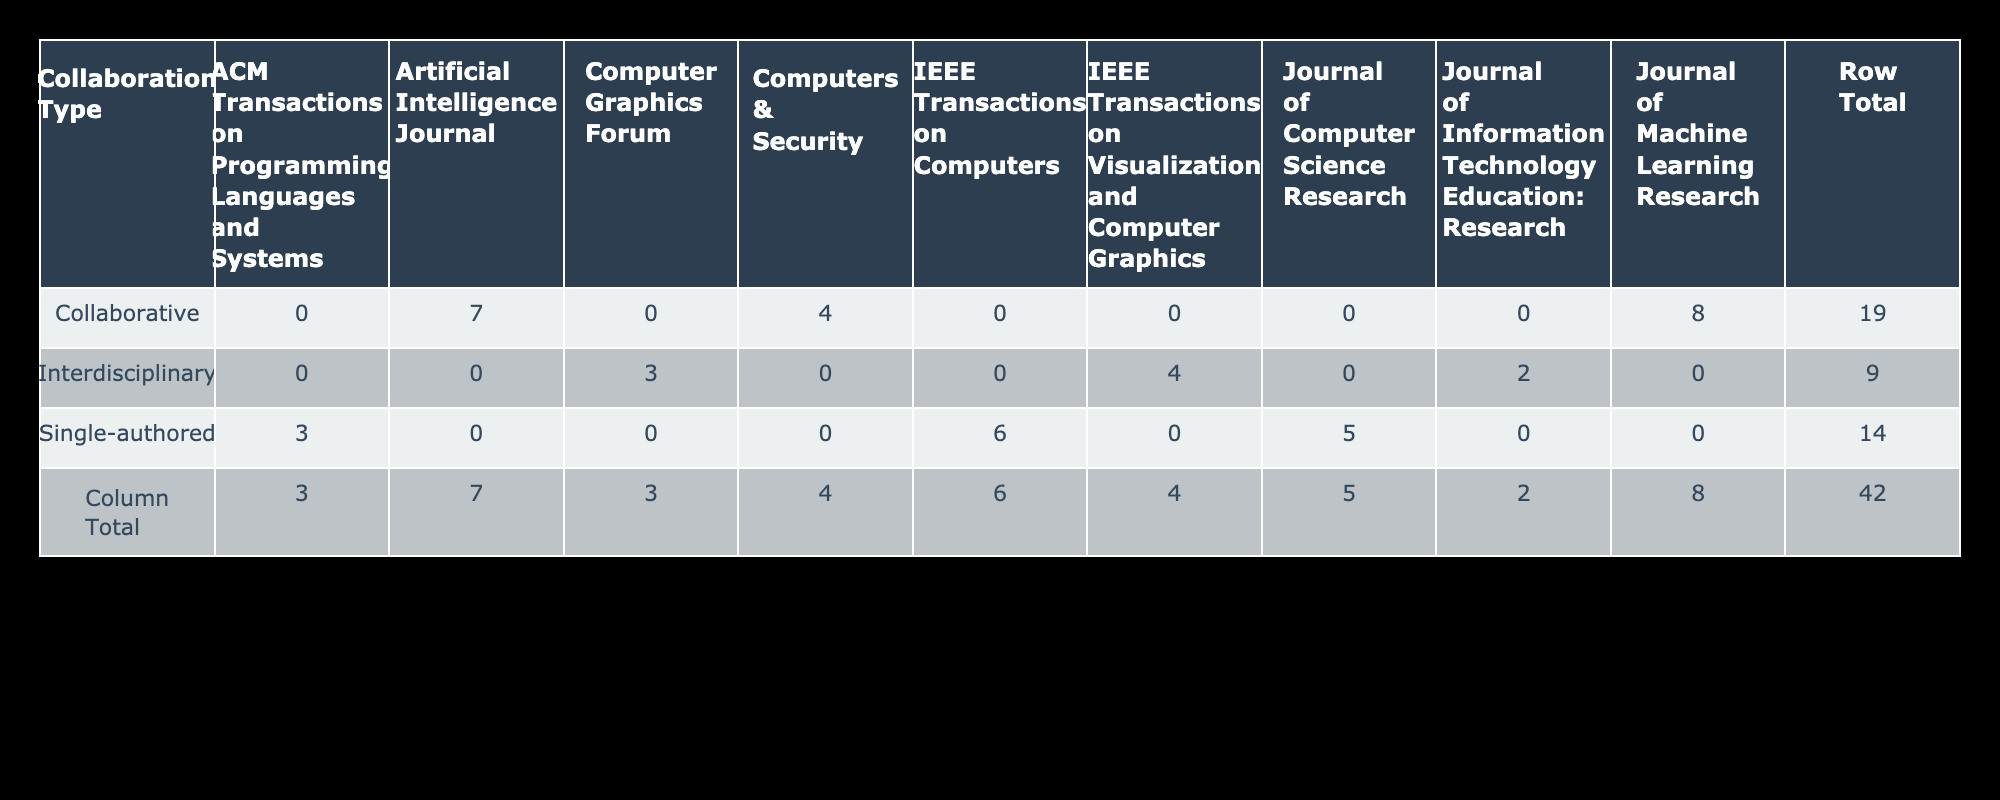What is the total number of publications for collaborative research? The table shows the publications for various collaboration types. For "Collaborative," there are 8 publications from the Journal of Machine Learning Research, 4 from Computers & Security, and 7 from Artificial Intelligence Journal. Adding these gives a total of 8 + 4 + 7 = 19 publications.
Answer: 19 Which journal has the highest impact factor among those listed? The impact factors of the listed journals are 3.2, 2.8, 4.1 for single-authored, 6.5, 4.3, 5.7 for collaborative, and 2.3, 3.8, 4.9 for interdisciplinary. The highest is 6.5 from the Journal of Machine Learning Research.
Answer: 6.5 Are there any single-authored publications in journals with an impact factor higher than 4.0? The impact factors for single-authored journals are 3.2, 2.8, and 4.1. Since 4.1 is the only single-authored journal that exceeds 4.0, the answer is yes, as there are 6 publications in that journal.
Answer: Yes What is the average number of publications for interdisciplinary collaboration? The interdisciplinary journals show 2 publications from Journal of Information Technology Education: Research, 3 from Computer Graphics Forum, and 4 from IEEE Transactions on Visualization and Computer Graphics. The total publications are 2 + 3 + 4 = 9, and since there are 3 journals, the average is 9 / 3 = 3.
Answer: 3 How many more publications are there in collaborative journals than in single-authored journals? The single-authored publications total to 5 + 3 + 6 = 14. The collaborative publications total to 19, as calculated earlier. The difference is 19 - 14 = 5 more publications in collaborative journals.
Answer: 5 Is it true that there are more interdisciplinary publications than single-authored publications? Single-authored publications total 14, while interdisciplinary publications total 2 + 3 + 4 = 9. Since 9 is less than 14, the statement is false.
Answer: No What percentage of total publications come from collaborative journals? The total publications across all types result in 14 (single-authored) + 19 (collaborative) + 9 (interdisciplinary) = 42. Collaborative journals contribute 19 publications. Calculating the percentage gives (19 / 42) * 100 ≈ 45.24%.
Answer: 45.24% How many collaborative journals have more than 5 publications? The collaborative journals have 8 publications from Journal of Machine Learning Research, 4 from Computers & Security, and 7 from Artificial Intelligence Journal. Only the Journal of Machine Learning Research and Artificial Intelligence Journal exceed 5 publications.
Answer: 2 